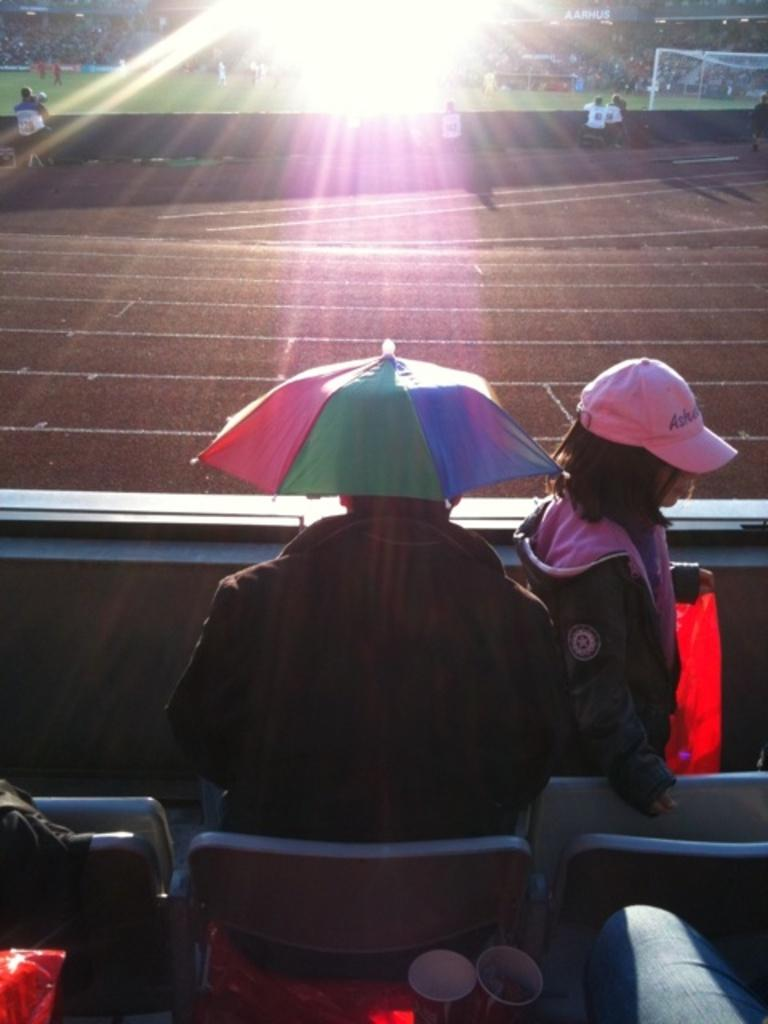Where are the spectators located in the image? The spectators are at the top of the image. What is happening on the ground in the image? There are persons in the ground. Can you describe the child in the image? There is a child at the bottom of the image. What is the person sitting on the chair doing? The person sitting on the chair has an umbrella. What type of paste is being used by the spectators to ring the bells in the image? There are no bells or paste present in the image. How many chairs are visible in the image? The image does not specify the number of chairs, but there is one person sitting on a chair with an umbrella. 